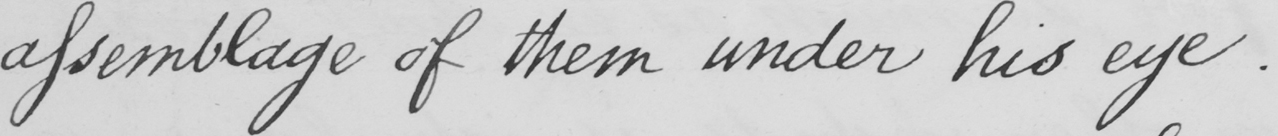What does this handwritten line say? assemblage of them under his eye . 